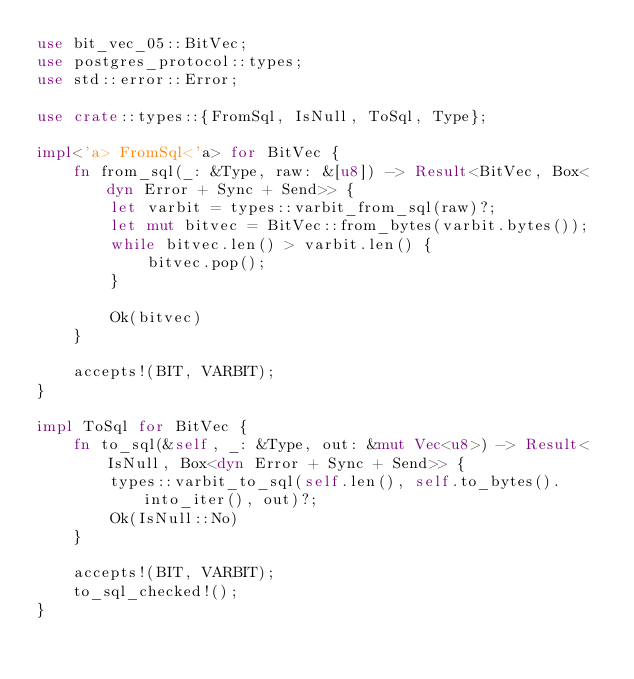Convert code to text. <code><loc_0><loc_0><loc_500><loc_500><_Rust_>use bit_vec_05::BitVec;
use postgres_protocol::types;
use std::error::Error;

use crate::types::{FromSql, IsNull, ToSql, Type};

impl<'a> FromSql<'a> for BitVec {
    fn from_sql(_: &Type, raw: &[u8]) -> Result<BitVec, Box<dyn Error + Sync + Send>> {
        let varbit = types::varbit_from_sql(raw)?;
        let mut bitvec = BitVec::from_bytes(varbit.bytes());
        while bitvec.len() > varbit.len() {
            bitvec.pop();
        }

        Ok(bitvec)
    }

    accepts!(BIT, VARBIT);
}

impl ToSql for BitVec {
    fn to_sql(&self, _: &Type, out: &mut Vec<u8>) -> Result<IsNull, Box<dyn Error + Sync + Send>> {
        types::varbit_to_sql(self.len(), self.to_bytes().into_iter(), out)?;
        Ok(IsNull::No)
    }

    accepts!(BIT, VARBIT);
    to_sql_checked!();
}
</code> 